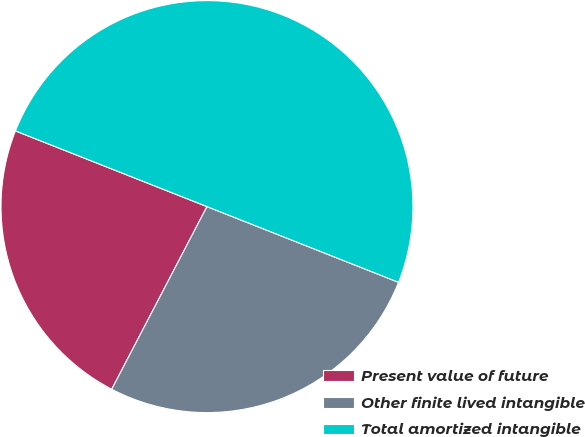<chart> <loc_0><loc_0><loc_500><loc_500><pie_chart><fcel>Present value of future<fcel>Other finite lived intangible<fcel>Total amortized intangible<nl><fcel>23.34%<fcel>26.66%<fcel>50.0%<nl></chart> 